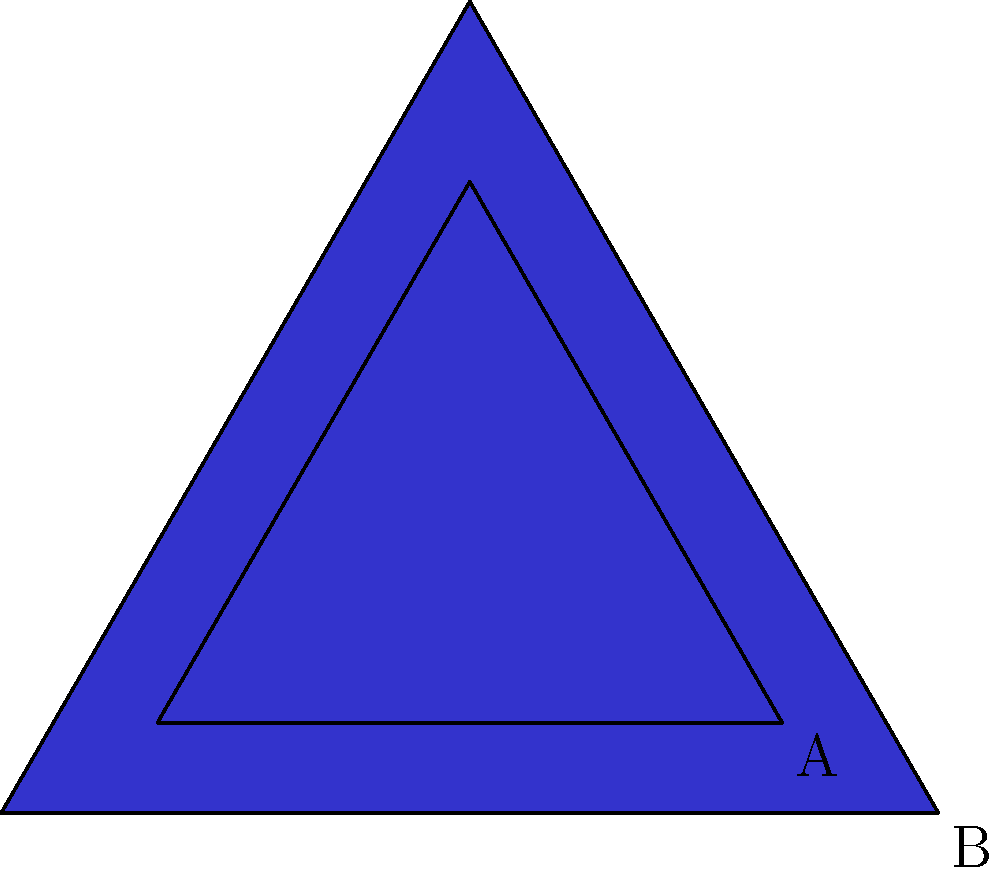In a study on aggressive behavior patterns in adolescents, triangle A represents the frequency of aggressive incidents for a group of 13-year-olds. Triangle B is a scaled version of triangle A, representing the same behavior for 16-year-olds. If the area of triangle B is 2.25 times the area of triangle A, by what factor has each side of triangle A been scaled to produce triangle B? To solve this problem, we'll use the relationship between scaling factors for area and length in similar shapes:

1) Let's denote the scaling factor for the sides as $s$.

2) For similar shapes, the ratio of their areas is equal to the square of the ratio of their corresponding sides. Mathematically, this is expressed as:

   $\frac{\text{Area}_B}{\text{Area}_A} = s^2$

3) We're given that the area of triangle B is 2.25 times the area of triangle A:

   $\frac{\text{Area}_B}{\text{Area}_A} = 2.25$

4) Substituting this into our equation:

   $2.25 = s^2$

5) To find $s$, we need to take the square root of both sides:

   $s = \sqrt{2.25}$

6) Simplify:
   
   $s = 1.5$

Therefore, each side of triangle A has been scaled by a factor of 1.5 to produce triangle B.
Answer: 1.5 